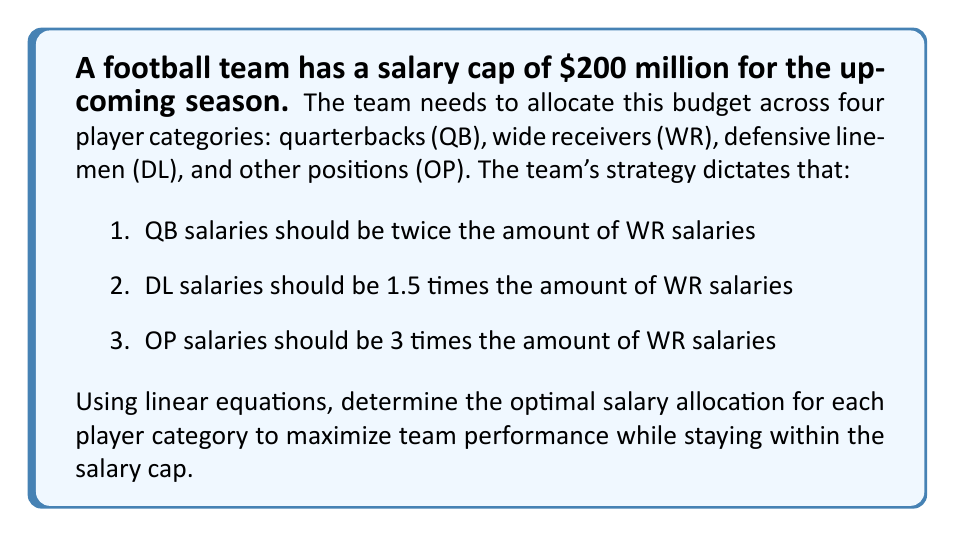Could you help me with this problem? Let's approach this step-by-step using linear equations:

1. Define variables:
   Let $x$ = WR salaries

2. Express other salaries in terms of $x$:
   QB salaries = $2x$
   DL salaries = $1.5x$
   OP salaries = $3x$

3. Set up the linear equation based on the salary cap:
   $$x + 2x + 1.5x + 3x = 200$$

4. Simplify the equation:
   $$7.5x = 200$$

5. Solve for $x$:
   $$x = \frac{200}{7.5} = 26.67$$

6. Calculate the salaries for each category:
   WR: $x = 26.67$ million
   QB: $2x = 2(26.67) = 53.34$ million
   DL: $1.5x = 1.5(26.67) = 40$ million
   OP: $3x = 3(26.67) = 80$ million

7. Verify the total:
   $$26.67 + 53.34 + 40 + 80 = 200$$ million (rounding errors account for the slight discrepancy)

Therefore, the optimal salary allocation is:
QB: $53.34 million
WR: $26.67 million
DL: $40 million
OP: $80 million
Answer: QB: $53.34M, WR: $26.67M, DL: $40M, OP: $80M 